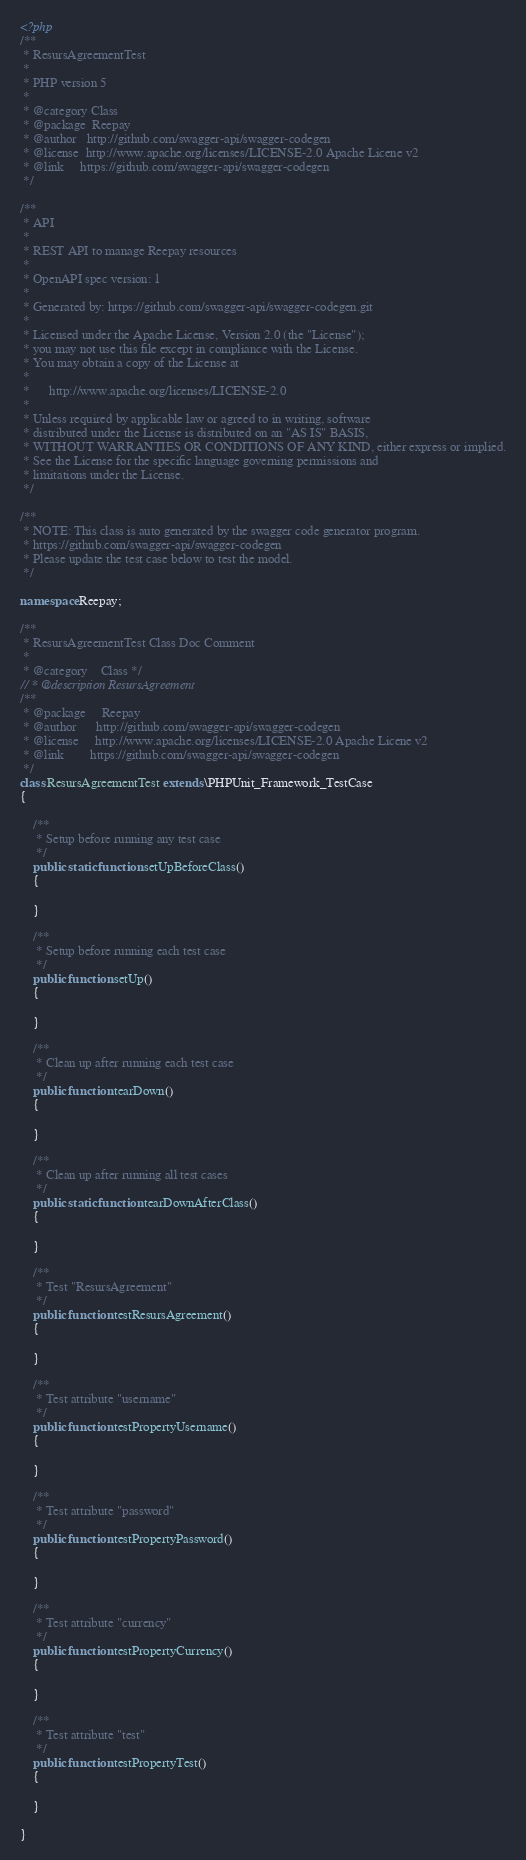Convert code to text. <code><loc_0><loc_0><loc_500><loc_500><_PHP_><?php
/**
 * ResursAgreementTest
 *
 * PHP version 5
 *
 * @category Class
 * @package  Reepay
 * @author   http://github.com/swagger-api/swagger-codegen
 * @license  http://www.apache.org/licenses/LICENSE-2.0 Apache Licene v2
 * @link     https://github.com/swagger-api/swagger-codegen
 */

/**
 * API
 *
 * REST API to manage Reepay resources
 *
 * OpenAPI spec version: 1
 * 
 * Generated by: https://github.com/swagger-api/swagger-codegen.git
 *
 * Licensed under the Apache License, Version 2.0 (the "License");
 * you may not use this file except in compliance with the License.
 * You may obtain a copy of the License at
 *
 *      http://www.apache.org/licenses/LICENSE-2.0
 *
 * Unless required by applicable law or agreed to in writing, software
 * distributed under the License is distributed on an "AS IS" BASIS,
 * WITHOUT WARRANTIES OR CONDITIONS OF ANY KIND, either express or implied.
 * See the License for the specific language governing permissions and
 * limitations under the License.
 */

/**
 * NOTE: This class is auto generated by the swagger code generator program.
 * https://github.com/swagger-api/swagger-codegen
 * Please update the test case below to test the model.
 */

namespace Reepay;

/**
 * ResursAgreementTest Class Doc Comment
 *
 * @category    Class */
// * @description ResursAgreement
/**
 * @package     Reepay
 * @author      http://github.com/swagger-api/swagger-codegen
 * @license     http://www.apache.org/licenses/LICENSE-2.0 Apache Licene v2
 * @link        https://github.com/swagger-api/swagger-codegen
 */
class ResursAgreementTest extends \PHPUnit_Framework_TestCase
{

    /**
     * Setup before running any test case
     */
    public static function setUpBeforeClass()
    {

    }

    /**
     * Setup before running each test case
     */
    public function setUp()
    {

    }

    /**
     * Clean up after running each test case
     */
    public function tearDown()
    {

    }

    /**
     * Clean up after running all test cases
     */
    public static function tearDownAfterClass()
    {

    }

    /**
     * Test "ResursAgreement"
     */
    public function testResursAgreement()
    {

    }

    /**
     * Test attribute "username"
     */
    public function testPropertyUsername()
    {

    }

    /**
     * Test attribute "password"
     */
    public function testPropertyPassword()
    {

    }

    /**
     * Test attribute "currency"
     */
    public function testPropertyCurrency()
    {

    }

    /**
     * Test attribute "test"
     */
    public function testPropertyTest()
    {

    }

}
</code> 